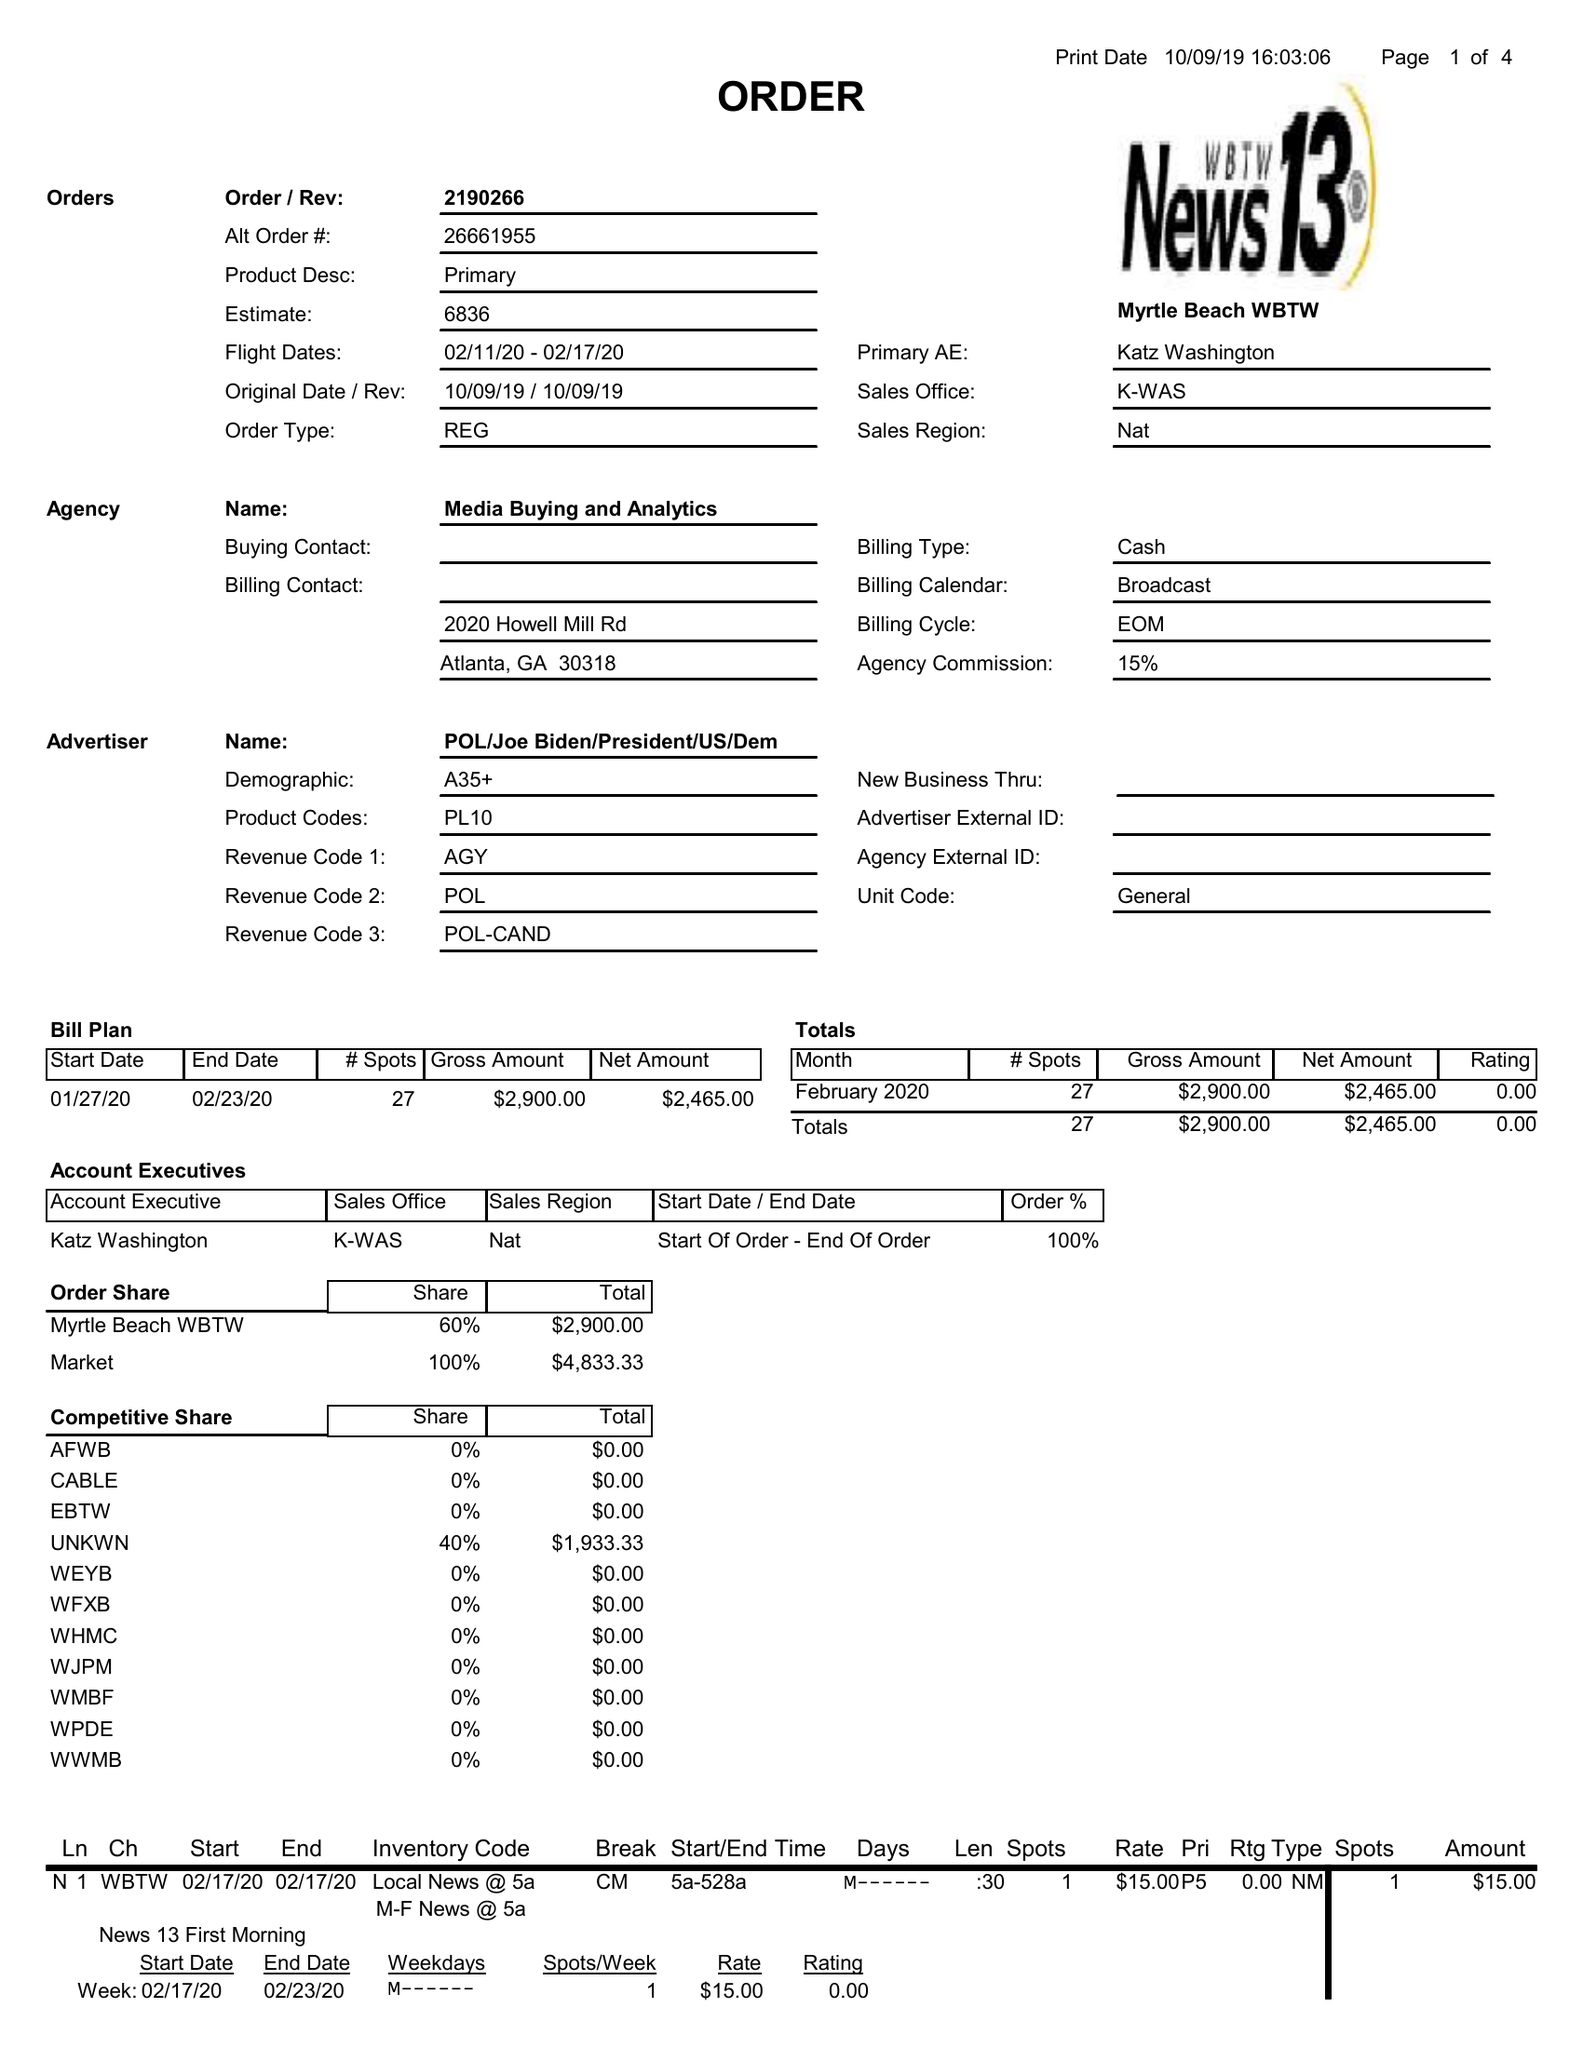What is the value for the flight_from?
Answer the question using a single word or phrase. 02/11/20 